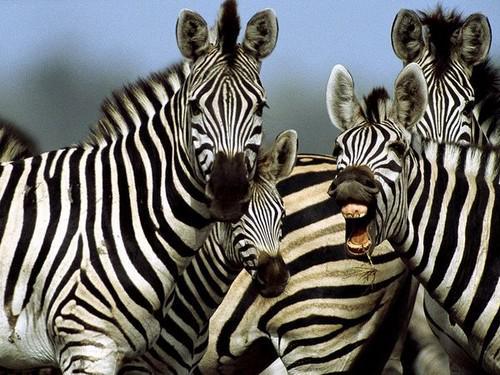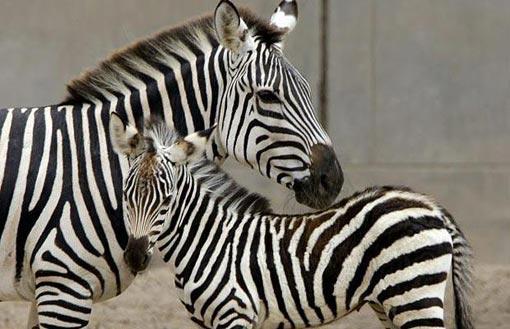The first image is the image on the left, the second image is the image on the right. Analyze the images presented: Is the assertion "There are at least two very young zebra here." valid? Answer yes or no. Yes. The first image is the image on the left, the second image is the image on the right. Assess this claim about the two images: "An image shows a zebra with its body facing left and its snout over the back of a smaller zebra.". Correct or not? Answer yes or no. Yes. 